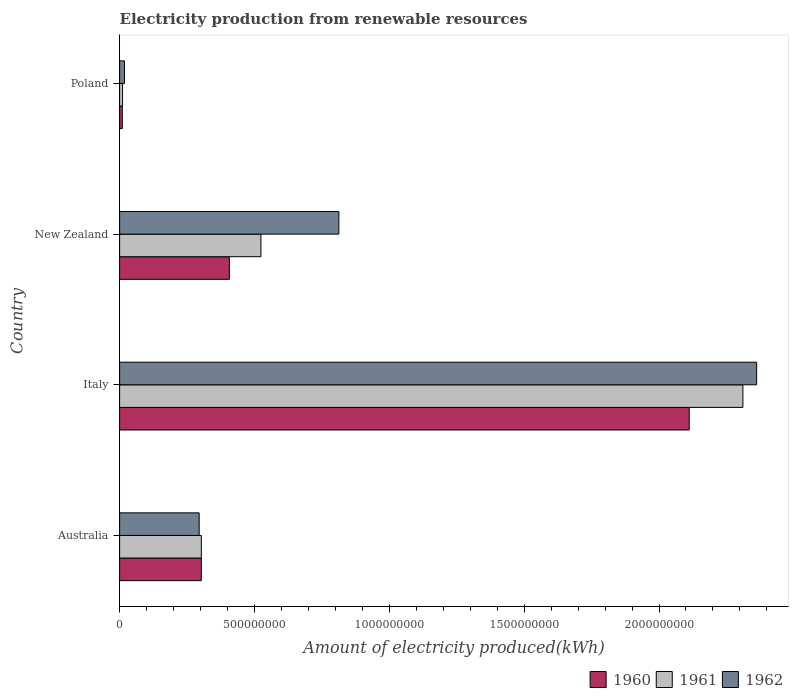How many different coloured bars are there?
Offer a very short reply. 3. How many groups of bars are there?
Your answer should be compact. 4. Are the number of bars on each tick of the Y-axis equal?
Make the answer very short. Yes. How many bars are there on the 2nd tick from the bottom?
Make the answer very short. 3. What is the label of the 2nd group of bars from the top?
Give a very brief answer. New Zealand. What is the amount of electricity produced in 1960 in Poland?
Offer a very short reply. 1.00e+07. Across all countries, what is the maximum amount of electricity produced in 1960?
Ensure brevity in your answer.  2.11e+09. Across all countries, what is the minimum amount of electricity produced in 1960?
Provide a short and direct response. 1.00e+07. What is the total amount of electricity produced in 1962 in the graph?
Provide a short and direct response. 3.49e+09. What is the difference between the amount of electricity produced in 1962 in Italy and that in Poland?
Provide a succinct answer. 2.34e+09. What is the difference between the amount of electricity produced in 1961 in Poland and the amount of electricity produced in 1962 in Italy?
Offer a terse response. -2.35e+09. What is the average amount of electricity produced in 1961 per country?
Ensure brevity in your answer.  7.87e+08. In how many countries, is the amount of electricity produced in 1961 greater than 1700000000 kWh?
Your answer should be very brief. 1. What is the ratio of the amount of electricity produced in 1961 in Australia to that in New Zealand?
Your answer should be very brief. 0.58. What is the difference between the highest and the second highest amount of electricity produced in 1960?
Offer a terse response. 1.70e+09. What is the difference between the highest and the lowest amount of electricity produced in 1961?
Offer a terse response. 2.30e+09. In how many countries, is the amount of electricity produced in 1961 greater than the average amount of electricity produced in 1961 taken over all countries?
Give a very brief answer. 1. What does the 2nd bar from the top in Italy represents?
Give a very brief answer. 1961. How many bars are there?
Keep it short and to the point. 12. Are all the bars in the graph horizontal?
Ensure brevity in your answer.  Yes. How many countries are there in the graph?
Provide a succinct answer. 4. What is the difference between two consecutive major ticks on the X-axis?
Your response must be concise. 5.00e+08. Does the graph contain grids?
Your answer should be compact. No. What is the title of the graph?
Provide a short and direct response. Electricity production from renewable resources. Does "1981" appear as one of the legend labels in the graph?
Ensure brevity in your answer.  No. What is the label or title of the X-axis?
Provide a succinct answer. Amount of electricity produced(kWh). What is the Amount of electricity produced(kWh) of 1960 in Australia?
Keep it short and to the point. 3.03e+08. What is the Amount of electricity produced(kWh) in 1961 in Australia?
Provide a short and direct response. 3.03e+08. What is the Amount of electricity produced(kWh) of 1962 in Australia?
Provide a succinct answer. 2.95e+08. What is the Amount of electricity produced(kWh) of 1960 in Italy?
Give a very brief answer. 2.11e+09. What is the Amount of electricity produced(kWh) of 1961 in Italy?
Offer a very short reply. 2.31e+09. What is the Amount of electricity produced(kWh) in 1962 in Italy?
Your answer should be very brief. 2.36e+09. What is the Amount of electricity produced(kWh) of 1960 in New Zealand?
Your response must be concise. 4.07e+08. What is the Amount of electricity produced(kWh) in 1961 in New Zealand?
Ensure brevity in your answer.  5.24e+08. What is the Amount of electricity produced(kWh) of 1962 in New Zealand?
Your response must be concise. 8.13e+08. What is the Amount of electricity produced(kWh) in 1960 in Poland?
Offer a terse response. 1.00e+07. What is the Amount of electricity produced(kWh) in 1961 in Poland?
Give a very brief answer. 1.10e+07. What is the Amount of electricity produced(kWh) in 1962 in Poland?
Keep it short and to the point. 1.80e+07. Across all countries, what is the maximum Amount of electricity produced(kWh) in 1960?
Provide a short and direct response. 2.11e+09. Across all countries, what is the maximum Amount of electricity produced(kWh) in 1961?
Your response must be concise. 2.31e+09. Across all countries, what is the maximum Amount of electricity produced(kWh) in 1962?
Your response must be concise. 2.36e+09. Across all countries, what is the minimum Amount of electricity produced(kWh) of 1960?
Provide a short and direct response. 1.00e+07. Across all countries, what is the minimum Amount of electricity produced(kWh) in 1961?
Provide a succinct answer. 1.10e+07. Across all countries, what is the minimum Amount of electricity produced(kWh) of 1962?
Provide a short and direct response. 1.80e+07. What is the total Amount of electricity produced(kWh) of 1960 in the graph?
Make the answer very short. 2.83e+09. What is the total Amount of electricity produced(kWh) in 1961 in the graph?
Provide a succinct answer. 3.15e+09. What is the total Amount of electricity produced(kWh) in 1962 in the graph?
Keep it short and to the point. 3.49e+09. What is the difference between the Amount of electricity produced(kWh) in 1960 in Australia and that in Italy?
Make the answer very short. -1.81e+09. What is the difference between the Amount of electricity produced(kWh) of 1961 in Australia and that in Italy?
Keep it short and to the point. -2.01e+09. What is the difference between the Amount of electricity produced(kWh) in 1962 in Australia and that in Italy?
Your answer should be compact. -2.07e+09. What is the difference between the Amount of electricity produced(kWh) in 1960 in Australia and that in New Zealand?
Provide a succinct answer. -1.04e+08. What is the difference between the Amount of electricity produced(kWh) in 1961 in Australia and that in New Zealand?
Offer a terse response. -2.21e+08. What is the difference between the Amount of electricity produced(kWh) of 1962 in Australia and that in New Zealand?
Ensure brevity in your answer.  -5.18e+08. What is the difference between the Amount of electricity produced(kWh) of 1960 in Australia and that in Poland?
Provide a short and direct response. 2.93e+08. What is the difference between the Amount of electricity produced(kWh) in 1961 in Australia and that in Poland?
Offer a terse response. 2.92e+08. What is the difference between the Amount of electricity produced(kWh) in 1962 in Australia and that in Poland?
Provide a short and direct response. 2.77e+08. What is the difference between the Amount of electricity produced(kWh) of 1960 in Italy and that in New Zealand?
Your response must be concise. 1.70e+09. What is the difference between the Amount of electricity produced(kWh) in 1961 in Italy and that in New Zealand?
Provide a succinct answer. 1.79e+09. What is the difference between the Amount of electricity produced(kWh) of 1962 in Italy and that in New Zealand?
Make the answer very short. 1.55e+09. What is the difference between the Amount of electricity produced(kWh) of 1960 in Italy and that in Poland?
Your answer should be compact. 2.10e+09. What is the difference between the Amount of electricity produced(kWh) in 1961 in Italy and that in Poland?
Make the answer very short. 2.30e+09. What is the difference between the Amount of electricity produced(kWh) in 1962 in Italy and that in Poland?
Provide a succinct answer. 2.34e+09. What is the difference between the Amount of electricity produced(kWh) in 1960 in New Zealand and that in Poland?
Provide a short and direct response. 3.97e+08. What is the difference between the Amount of electricity produced(kWh) in 1961 in New Zealand and that in Poland?
Give a very brief answer. 5.13e+08. What is the difference between the Amount of electricity produced(kWh) of 1962 in New Zealand and that in Poland?
Your answer should be very brief. 7.95e+08. What is the difference between the Amount of electricity produced(kWh) in 1960 in Australia and the Amount of electricity produced(kWh) in 1961 in Italy?
Ensure brevity in your answer.  -2.01e+09. What is the difference between the Amount of electricity produced(kWh) of 1960 in Australia and the Amount of electricity produced(kWh) of 1962 in Italy?
Provide a succinct answer. -2.06e+09. What is the difference between the Amount of electricity produced(kWh) of 1961 in Australia and the Amount of electricity produced(kWh) of 1962 in Italy?
Ensure brevity in your answer.  -2.06e+09. What is the difference between the Amount of electricity produced(kWh) in 1960 in Australia and the Amount of electricity produced(kWh) in 1961 in New Zealand?
Your response must be concise. -2.21e+08. What is the difference between the Amount of electricity produced(kWh) in 1960 in Australia and the Amount of electricity produced(kWh) in 1962 in New Zealand?
Offer a very short reply. -5.10e+08. What is the difference between the Amount of electricity produced(kWh) in 1961 in Australia and the Amount of electricity produced(kWh) in 1962 in New Zealand?
Ensure brevity in your answer.  -5.10e+08. What is the difference between the Amount of electricity produced(kWh) of 1960 in Australia and the Amount of electricity produced(kWh) of 1961 in Poland?
Offer a very short reply. 2.92e+08. What is the difference between the Amount of electricity produced(kWh) of 1960 in Australia and the Amount of electricity produced(kWh) of 1962 in Poland?
Provide a short and direct response. 2.85e+08. What is the difference between the Amount of electricity produced(kWh) of 1961 in Australia and the Amount of electricity produced(kWh) of 1962 in Poland?
Offer a very short reply. 2.85e+08. What is the difference between the Amount of electricity produced(kWh) in 1960 in Italy and the Amount of electricity produced(kWh) in 1961 in New Zealand?
Your answer should be compact. 1.59e+09. What is the difference between the Amount of electricity produced(kWh) of 1960 in Italy and the Amount of electricity produced(kWh) of 1962 in New Zealand?
Your answer should be compact. 1.30e+09. What is the difference between the Amount of electricity produced(kWh) of 1961 in Italy and the Amount of electricity produced(kWh) of 1962 in New Zealand?
Make the answer very short. 1.50e+09. What is the difference between the Amount of electricity produced(kWh) in 1960 in Italy and the Amount of electricity produced(kWh) in 1961 in Poland?
Offer a terse response. 2.10e+09. What is the difference between the Amount of electricity produced(kWh) of 1960 in Italy and the Amount of electricity produced(kWh) of 1962 in Poland?
Offer a very short reply. 2.09e+09. What is the difference between the Amount of electricity produced(kWh) of 1961 in Italy and the Amount of electricity produced(kWh) of 1962 in Poland?
Your response must be concise. 2.29e+09. What is the difference between the Amount of electricity produced(kWh) in 1960 in New Zealand and the Amount of electricity produced(kWh) in 1961 in Poland?
Provide a short and direct response. 3.96e+08. What is the difference between the Amount of electricity produced(kWh) in 1960 in New Zealand and the Amount of electricity produced(kWh) in 1962 in Poland?
Provide a succinct answer. 3.89e+08. What is the difference between the Amount of electricity produced(kWh) in 1961 in New Zealand and the Amount of electricity produced(kWh) in 1962 in Poland?
Offer a terse response. 5.06e+08. What is the average Amount of electricity produced(kWh) in 1960 per country?
Offer a terse response. 7.08e+08. What is the average Amount of electricity produced(kWh) in 1961 per country?
Ensure brevity in your answer.  7.87e+08. What is the average Amount of electricity produced(kWh) in 1962 per country?
Keep it short and to the point. 8.72e+08. What is the difference between the Amount of electricity produced(kWh) in 1960 and Amount of electricity produced(kWh) in 1961 in Australia?
Ensure brevity in your answer.  0. What is the difference between the Amount of electricity produced(kWh) in 1960 and Amount of electricity produced(kWh) in 1961 in Italy?
Make the answer very short. -1.99e+08. What is the difference between the Amount of electricity produced(kWh) in 1960 and Amount of electricity produced(kWh) in 1962 in Italy?
Offer a very short reply. -2.50e+08. What is the difference between the Amount of electricity produced(kWh) of 1961 and Amount of electricity produced(kWh) of 1962 in Italy?
Offer a terse response. -5.10e+07. What is the difference between the Amount of electricity produced(kWh) of 1960 and Amount of electricity produced(kWh) of 1961 in New Zealand?
Provide a succinct answer. -1.17e+08. What is the difference between the Amount of electricity produced(kWh) in 1960 and Amount of electricity produced(kWh) in 1962 in New Zealand?
Keep it short and to the point. -4.06e+08. What is the difference between the Amount of electricity produced(kWh) in 1961 and Amount of electricity produced(kWh) in 1962 in New Zealand?
Ensure brevity in your answer.  -2.89e+08. What is the difference between the Amount of electricity produced(kWh) in 1960 and Amount of electricity produced(kWh) in 1961 in Poland?
Your answer should be compact. -1.00e+06. What is the difference between the Amount of electricity produced(kWh) in 1960 and Amount of electricity produced(kWh) in 1962 in Poland?
Give a very brief answer. -8.00e+06. What is the difference between the Amount of electricity produced(kWh) of 1961 and Amount of electricity produced(kWh) of 1962 in Poland?
Provide a succinct answer. -7.00e+06. What is the ratio of the Amount of electricity produced(kWh) of 1960 in Australia to that in Italy?
Provide a short and direct response. 0.14. What is the ratio of the Amount of electricity produced(kWh) of 1961 in Australia to that in Italy?
Your response must be concise. 0.13. What is the ratio of the Amount of electricity produced(kWh) of 1962 in Australia to that in Italy?
Provide a succinct answer. 0.12. What is the ratio of the Amount of electricity produced(kWh) of 1960 in Australia to that in New Zealand?
Give a very brief answer. 0.74. What is the ratio of the Amount of electricity produced(kWh) in 1961 in Australia to that in New Zealand?
Offer a terse response. 0.58. What is the ratio of the Amount of electricity produced(kWh) in 1962 in Australia to that in New Zealand?
Your answer should be compact. 0.36. What is the ratio of the Amount of electricity produced(kWh) of 1960 in Australia to that in Poland?
Ensure brevity in your answer.  30.3. What is the ratio of the Amount of electricity produced(kWh) of 1961 in Australia to that in Poland?
Give a very brief answer. 27.55. What is the ratio of the Amount of electricity produced(kWh) in 1962 in Australia to that in Poland?
Your response must be concise. 16.39. What is the ratio of the Amount of electricity produced(kWh) in 1960 in Italy to that in New Zealand?
Ensure brevity in your answer.  5.19. What is the ratio of the Amount of electricity produced(kWh) in 1961 in Italy to that in New Zealand?
Offer a terse response. 4.41. What is the ratio of the Amount of electricity produced(kWh) of 1962 in Italy to that in New Zealand?
Provide a succinct answer. 2.91. What is the ratio of the Amount of electricity produced(kWh) of 1960 in Italy to that in Poland?
Your response must be concise. 211.2. What is the ratio of the Amount of electricity produced(kWh) in 1961 in Italy to that in Poland?
Give a very brief answer. 210.09. What is the ratio of the Amount of electricity produced(kWh) of 1962 in Italy to that in Poland?
Make the answer very short. 131.22. What is the ratio of the Amount of electricity produced(kWh) of 1960 in New Zealand to that in Poland?
Provide a short and direct response. 40.7. What is the ratio of the Amount of electricity produced(kWh) in 1961 in New Zealand to that in Poland?
Your answer should be compact. 47.64. What is the ratio of the Amount of electricity produced(kWh) in 1962 in New Zealand to that in Poland?
Offer a very short reply. 45.17. What is the difference between the highest and the second highest Amount of electricity produced(kWh) of 1960?
Your answer should be very brief. 1.70e+09. What is the difference between the highest and the second highest Amount of electricity produced(kWh) of 1961?
Provide a short and direct response. 1.79e+09. What is the difference between the highest and the second highest Amount of electricity produced(kWh) in 1962?
Ensure brevity in your answer.  1.55e+09. What is the difference between the highest and the lowest Amount of electricity produced(kWh) in 1960?
Offer a terse response. 2.10e+09. What is the difference between the highest and the lowest Amount of electricity produced(kWh) of 1961?
Give a very brief answer. 2.30e+09. What is the difference between the highest and the lowest Amount of electricity produced(kWh) of 1962?
Ensure brevity in your answer.  2.34e+09. 